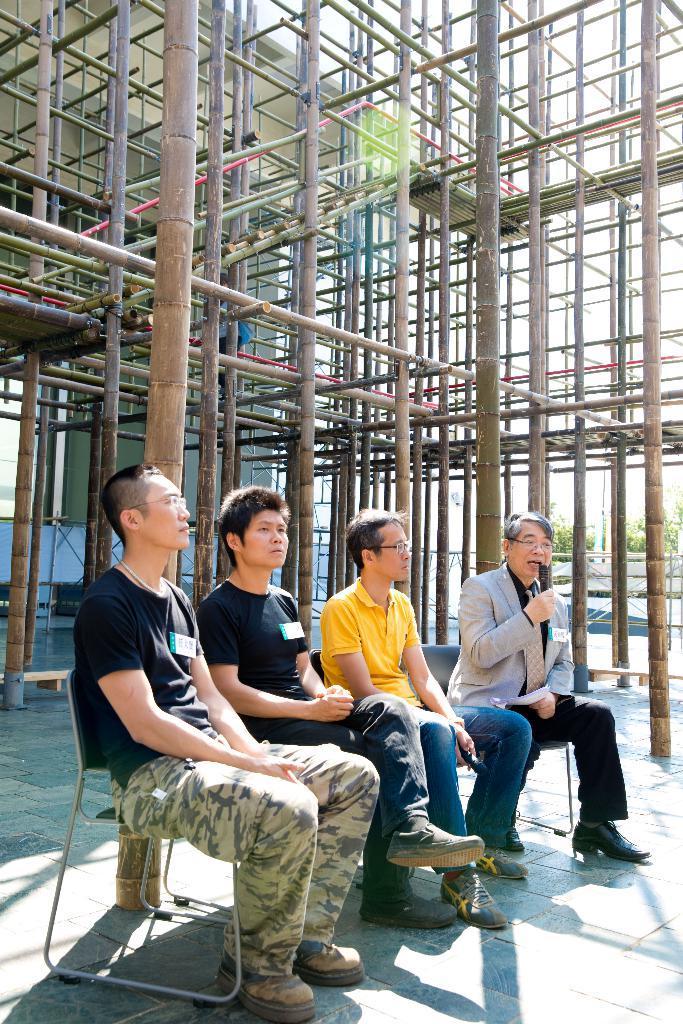Could you give a brief overview of what you see in this image? In this image, I can see four persons sitting on the chairs. In the background, I can see bamboo sticks, a building, trees and there is the sky. 